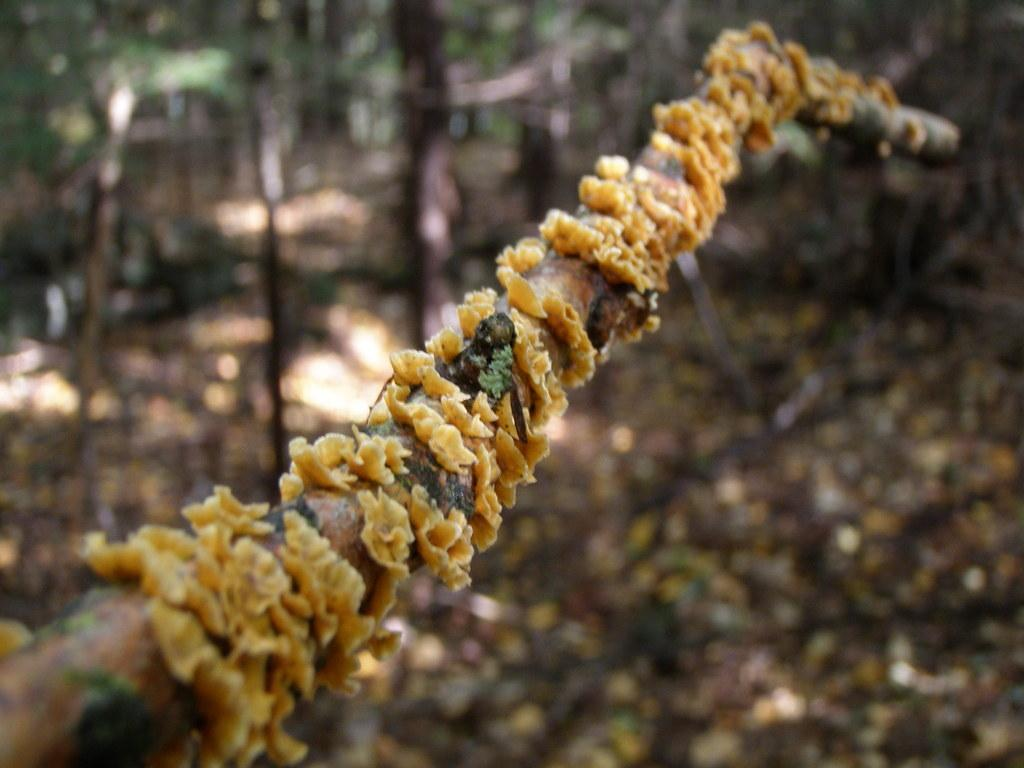What is the main subject of the image? The main subject of the image is a fungus on a stick. What type of environment is depicted in the image? The setting appears to be a forest. How is the background of the image presented? The background is blurred. What lesson is the grandmother teaching in the image? There is no grandmother or teaching activity present in the image; it features a fungus on a stick in a forest setting. 